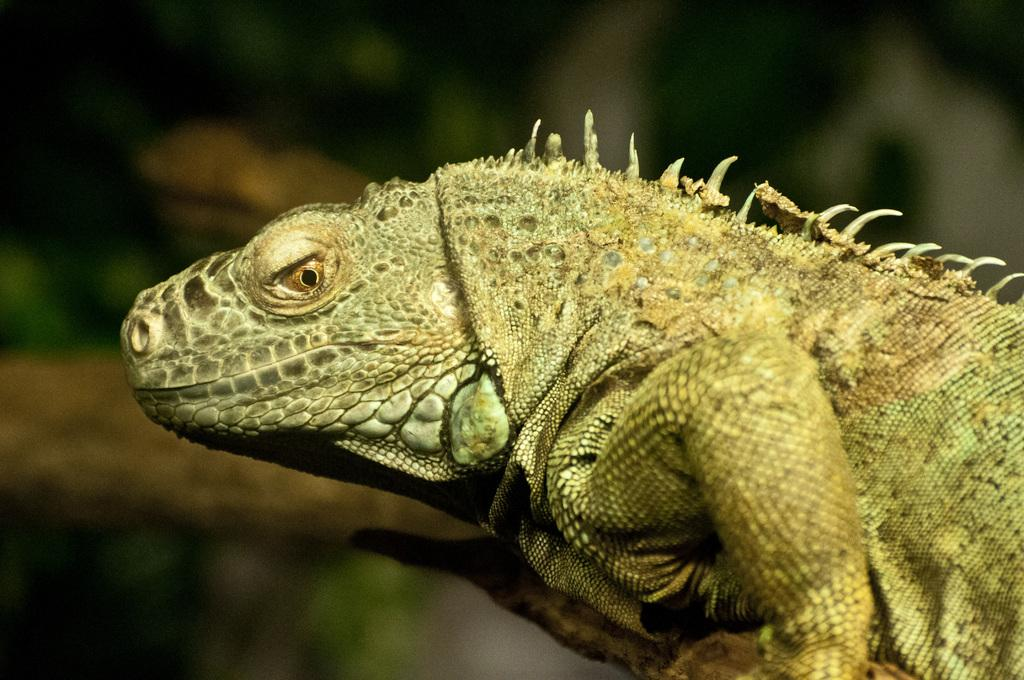What is the main subject in the foreground of the image? There is a chameleon in the foreground of the image. What can be seen in the background of the image? There are plants in the background of the image. What type of zipper can be seen on the chameleon's sock in the image? There is no zipper or sock present on the chameleon in the image. Can you tell me where the nearest airport is in relation to the chameleon in the image? The image does not provide any information about the location of an airport in relation to the chameleon. 